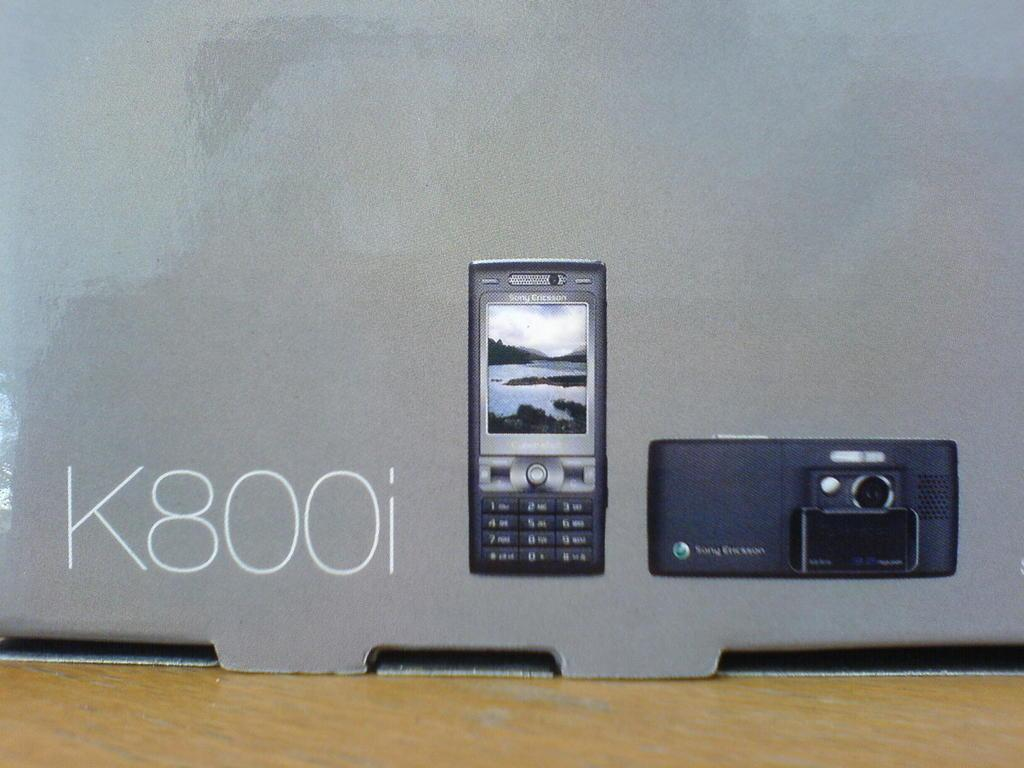<image>
Summarize the visual content of the image. A Sony Ericsson phone with the code K800i. 